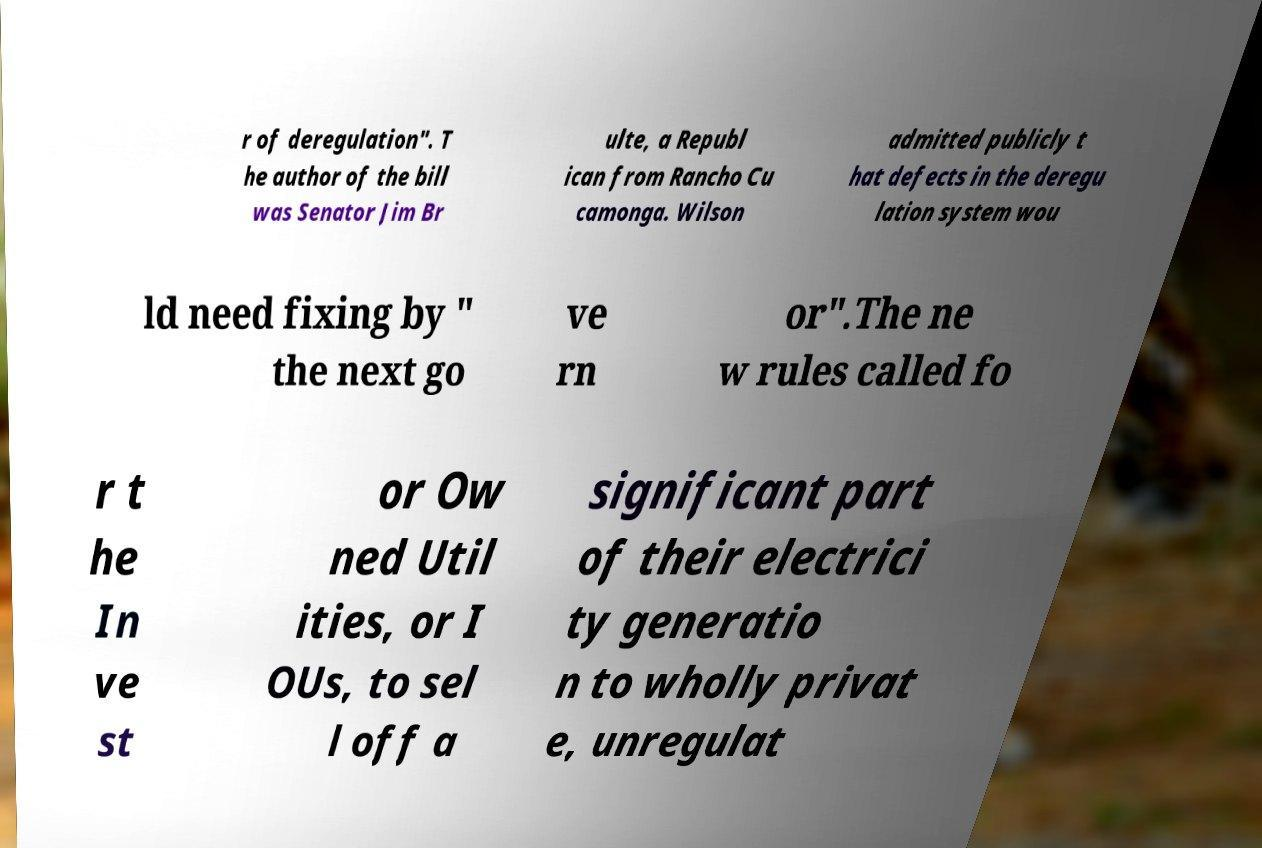Please identify and transcribe the text found in this image. r of deregulation". T he author of the bill was Senator Jim Br ulte, a Republ ican from Rancho Cu camonga. Wilson admitted publicly t hat defects in the deregu lation system wou ld need fixing by " the next go ve rn or".The ne w rules called fo r t he In ve st or Ow ned Util ities, or I OUs, to sel l off a significant part of their electrici ty generatio n to wholly privat e, unregulat 